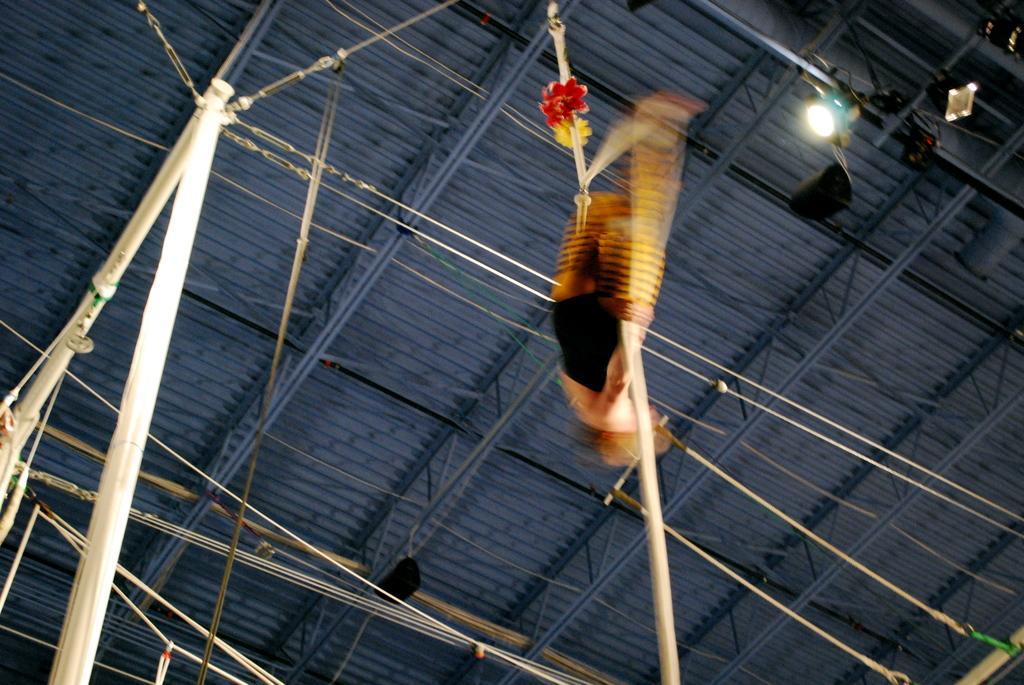Can you describe this image briefly? In the center of the picture there is a person performing acrobatics. On the left there are iron poles. In the center of the picture there are ropes and cables. At the top there is a light and there is ceiling. 